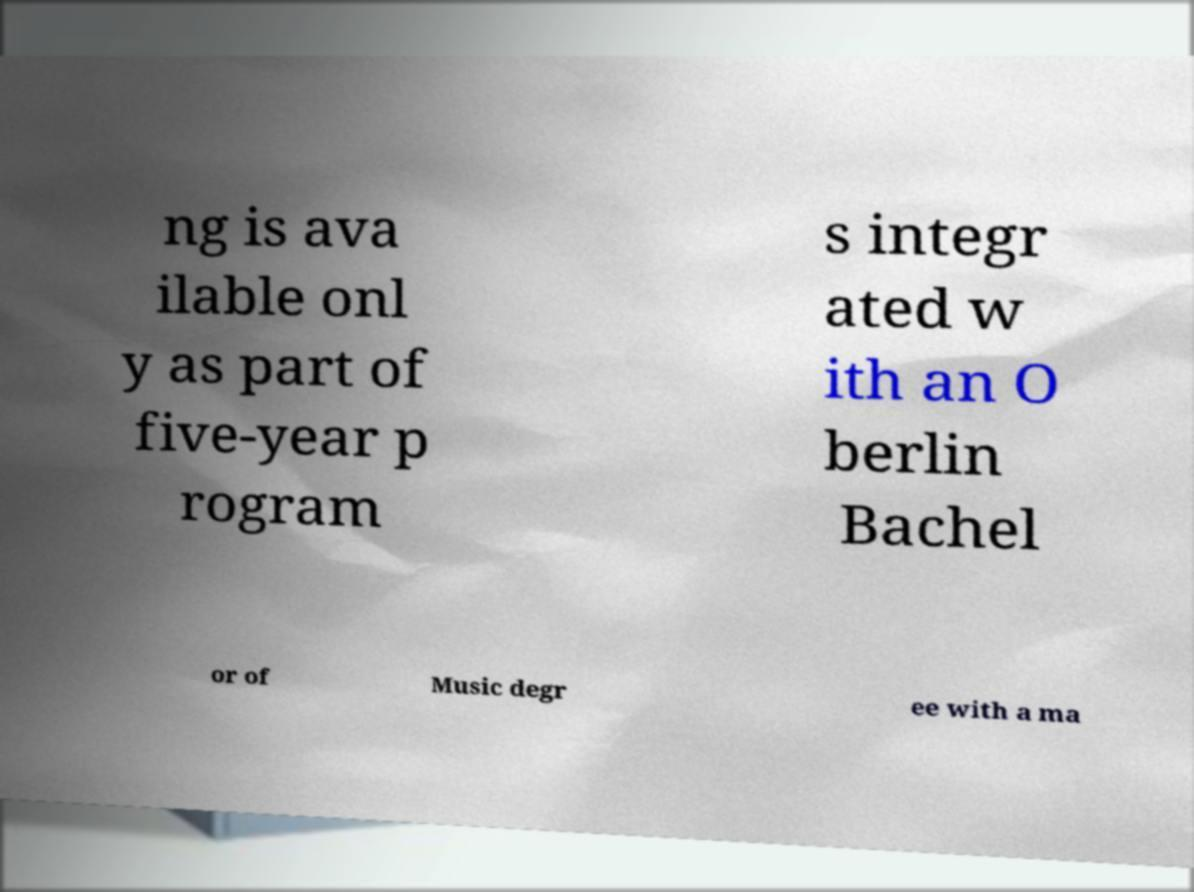I need the written content from this picture converted into text. Can you do that? ng is ava ilable onl y as part of five-year p rogram s integr ated w ith an O berlin Bachel or of Music degr ee with a ma 